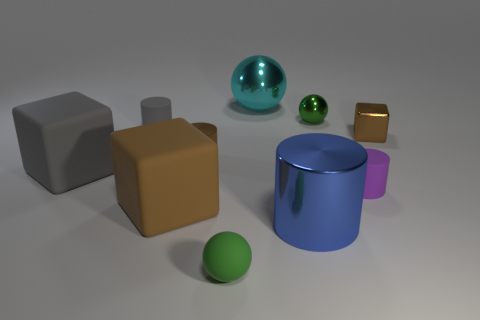Subtract all cylinders. How many objects are left? 6 Subtract all small metallic objects. Subtract all green balls. How many objects are left? 5 Add 1 small green objects. How many small green objects are left? 3 Add 2 cylinders. How many cylinders exist? 6 Subtract 0 blue cubes. How many objects are left? 10 